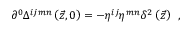<formula> <loc_0><loc_0><loc_500><loc_500>\partial ^ { 0 } \Delta ^ { i j m n } \left ( \vec { z } , 0 \right ) = - \eta ^ { i j } \eta ^ { m n } \delta ^ { 2 } \left ( \vec { z } \right ) \, ,</formula> 